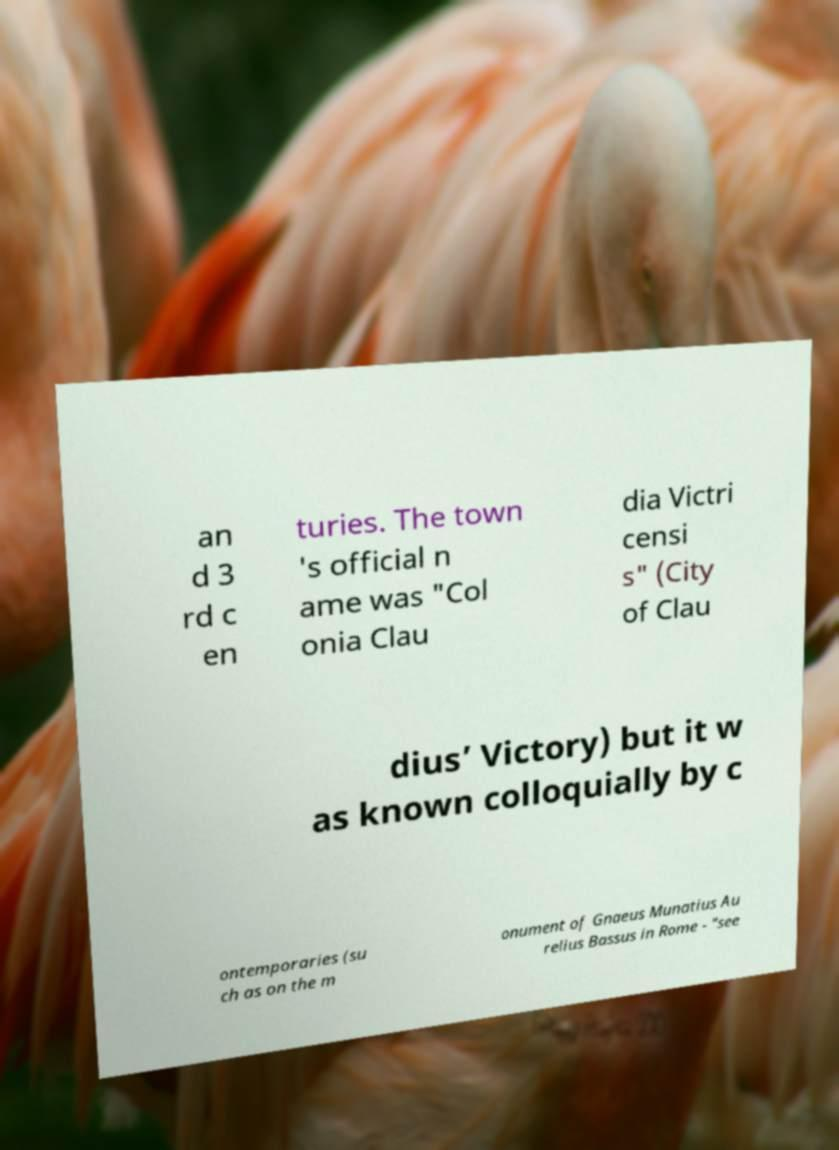Can you read and provide the text displayed in the image?This photo seems to have some interesting text. Can you extract and type it out for me? an d 3 rd c en turies. The town 's official n ame was "Col onia Clau dia Victri censi s" (City of Clau dius’ Victory) but it w as known colloquially by c ontemporaries (su ch as on the m onument of Gnaeus Munatius Au relius Bassus in Rome - "see 